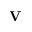Convert formula to latex. <formula><loc_0><loc_0><loc_500><loc_500>V</formula> 